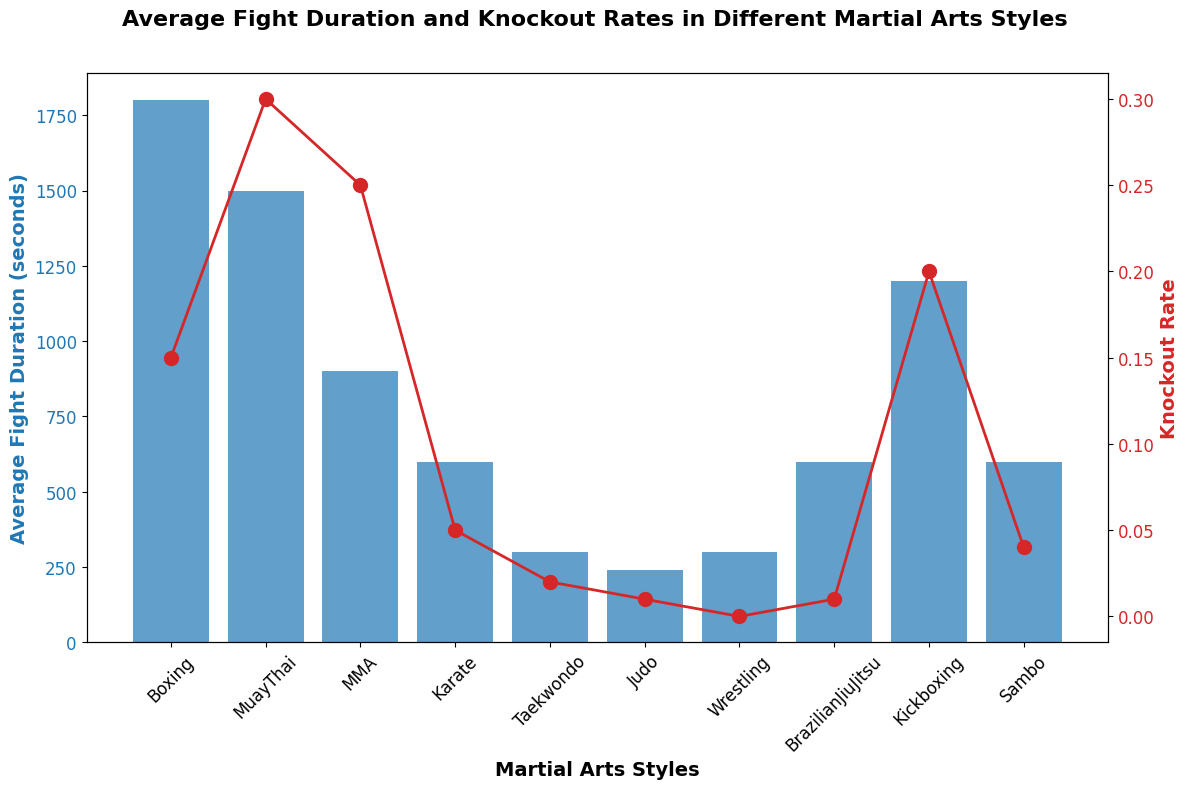what's the martial art style with the longest average fight duration? The chart displays "Average Fight Duration" in blue bars. Scanning through the length of the bars, Boxing has the longest bar indicating the highest average duration of 1800 seconds.
Answer: Boxing which martial art has the highest knockout rate? The chart shows knockout rates with red lines. The style with the highest point on the red line is Muay Thai, which has a knockout rate of 0.30.
Answer: Muay Thai compare the average fight duration of Judo and Karate. Which one is longer? Judo's bar reaches 240 seconds, whereas Karate's bar is taller at 600 seconds. Therefore, Karate has a longer average fight duration.
Answer: Karate what’s the difference in average fight duration between MMA and Taekwondo? The blue bar for MMA shows an average duration of 900 seconds, and Taekwondo's bar shows 300 seconds. The difference is 900 - 300 = 600 seconds.
Answer: 600 seconds which martial art styles have a knockout rate of 0.01? The red dots on Brazilian JiuJitsu, Judo, and Wrestling are at the 0.01 level. Hence, these three styles have a knockout rate of 0.01.
Answer: Brazilian JiuJitsu, Judo what’s the sum of average fight durations for styles with a knockout rate above 0.20? Styles with a knockout rate above 0.20 are Muay Thai (1500s) and MMA (900s). Summing these gives 1500 + 900 = 2400 seconds.
Answer: 2400 seconds which style has a higher knockout rate, Boxing or Kickboxing? At a glance, Boxing has a knockout rate of 0.15, and Kickboxing has 0.20. Thus, Kickboxing has a higher knockout rate.
Answer: Kickboxing compare the average fight duration of Kickboxing with Muay Thai, which is longer and by how much? Kickboxing has an average duration of 1200 seconds, whereas Muay Thai shows 1500 seconds. The difference is 1500 - 1200 = 300 seconds in favor of Muay Thai.
Answer: Muay Thai by 300 seconds which martial arts styles have the shortest average fight duration and what is the duration? The shortest blue bar is for Judo, indicating 240 seconds.
Answer: Judo, 240 seconds compare the knockout rate of Karate and Taekwondo. Which one is higher? The red line for Karate is at 0.05, and Taekwondo is at 0.02. Therefore, Karate has a higher knockout rate.
Answer: Karate 